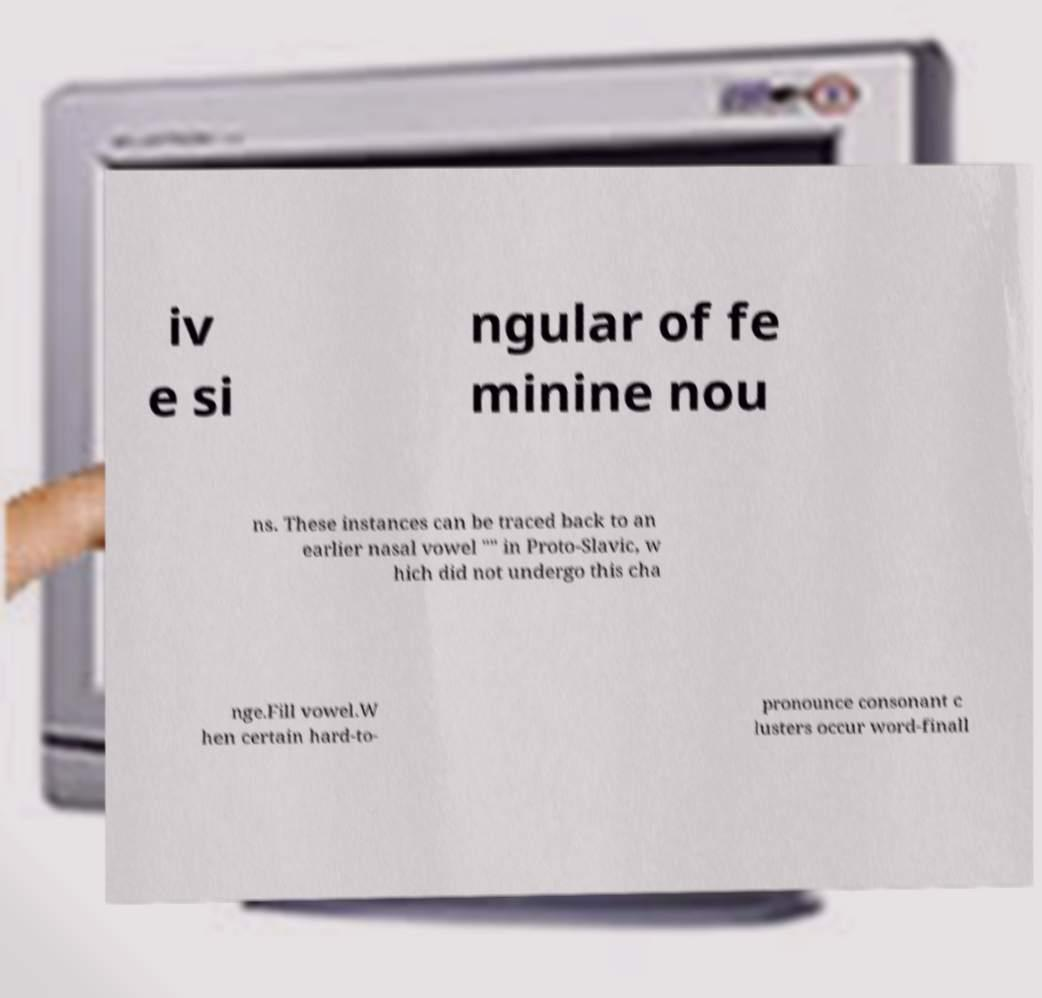Can you accurately transcribe the text from the provided image for me? iv e si ngular of fe minine nou ns. These instances can be traced back to an earlier nasal vowel "" in Proto-Slavic, w hich did not undergo this cha nge.Fill vowel.W hen certain hard-to- pronounce consonant c lusters occur word-finall 